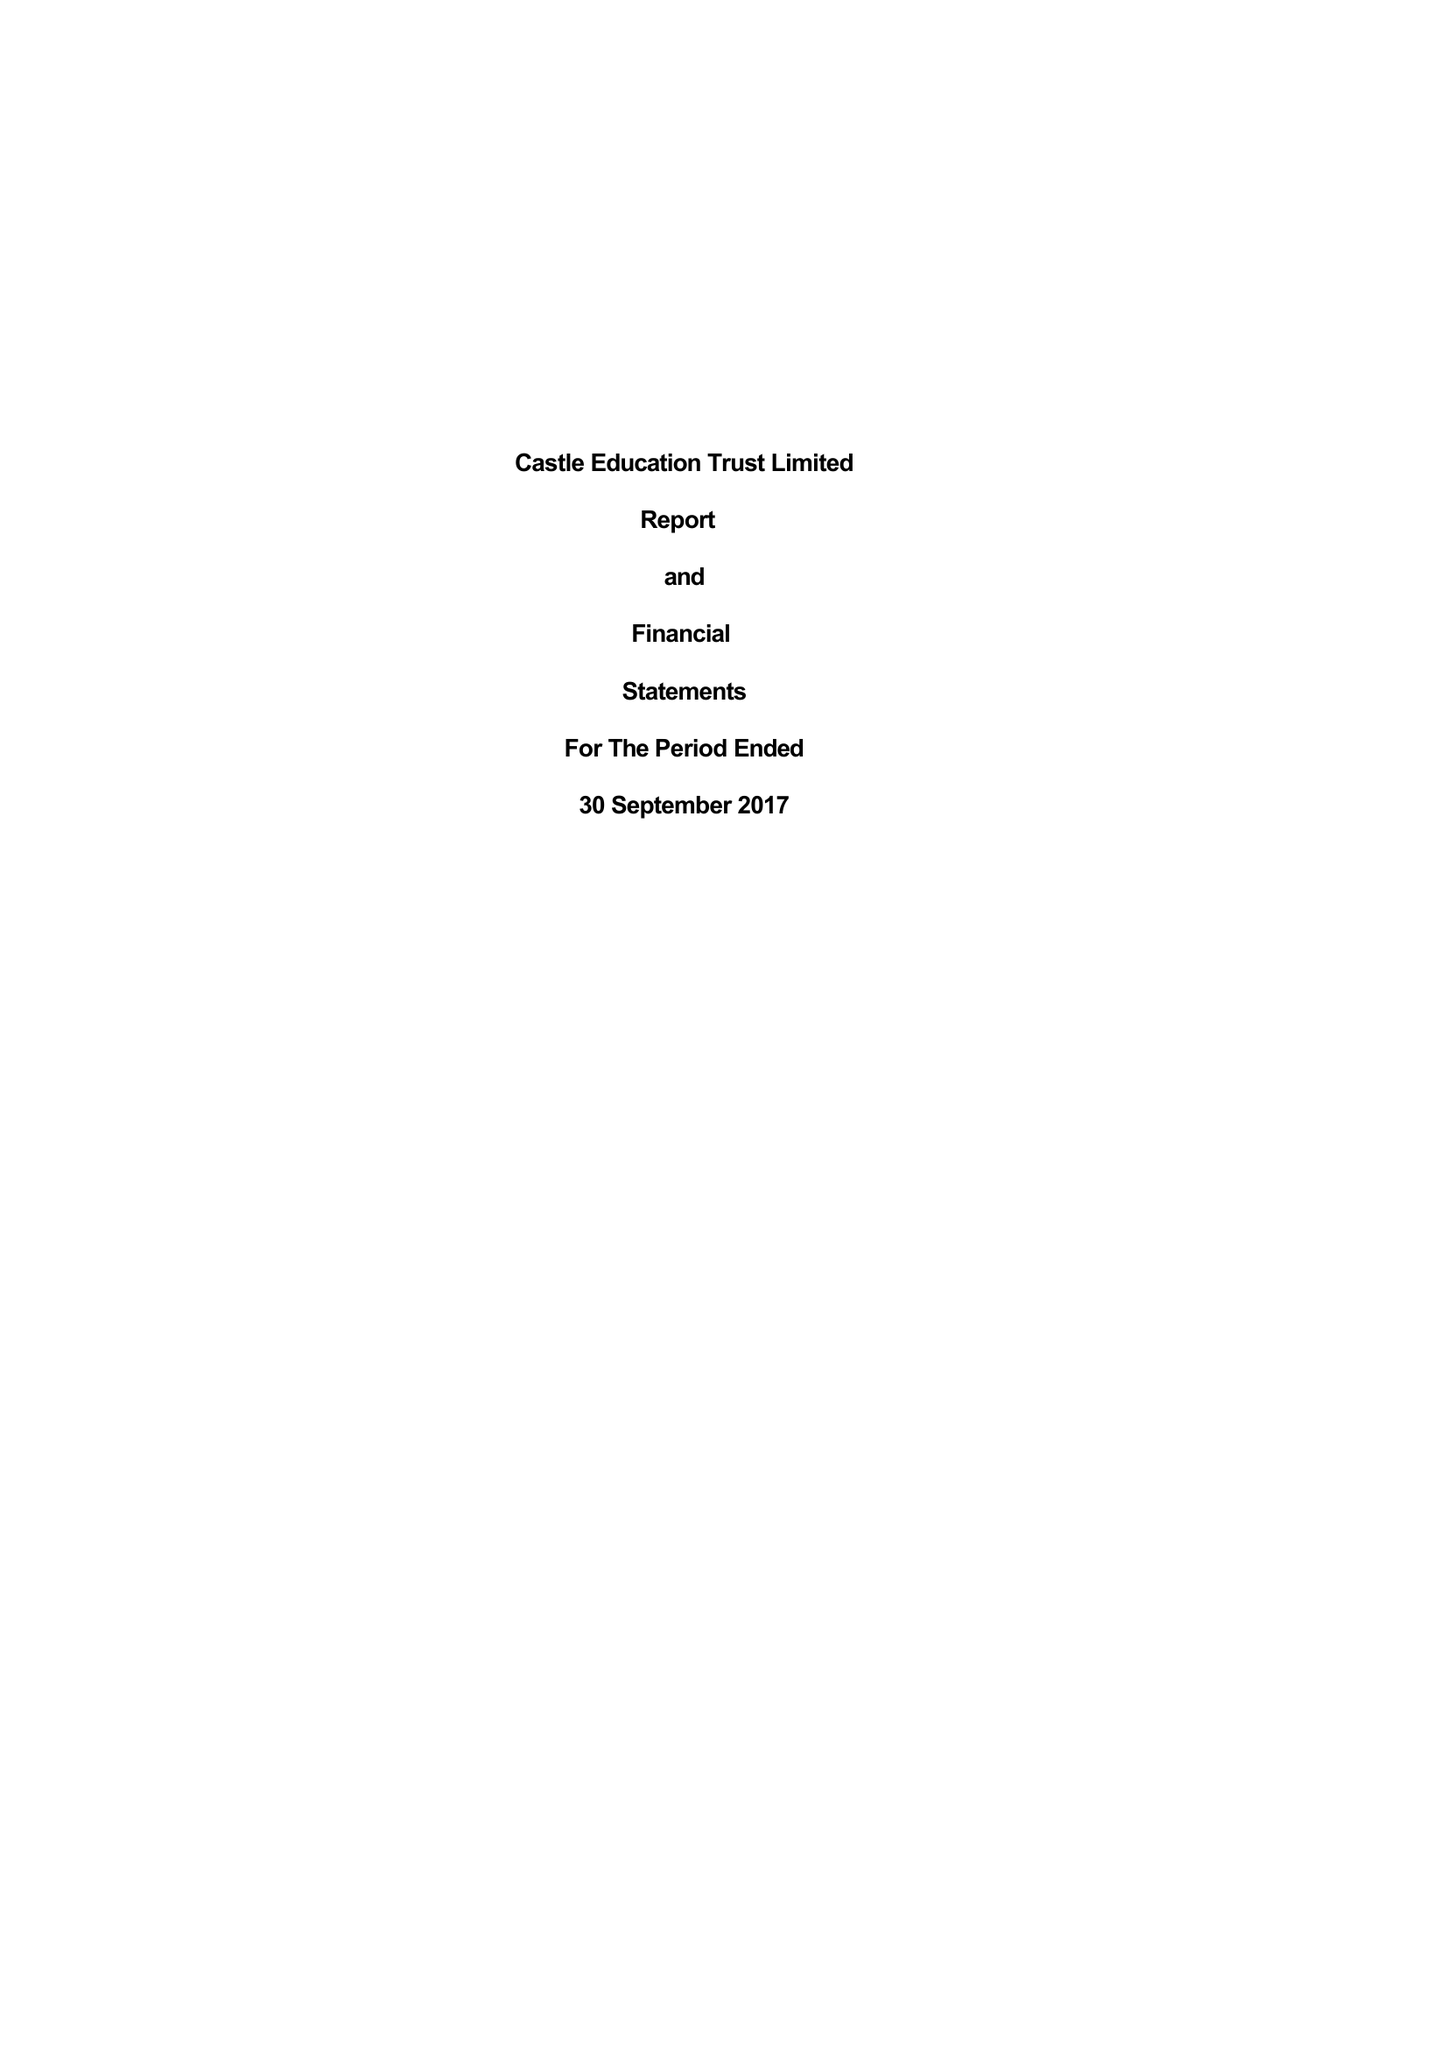What is the value for the address__street_line?
Answer the question using a single word or phrase. 50 CRAVEN PARK ROAD 